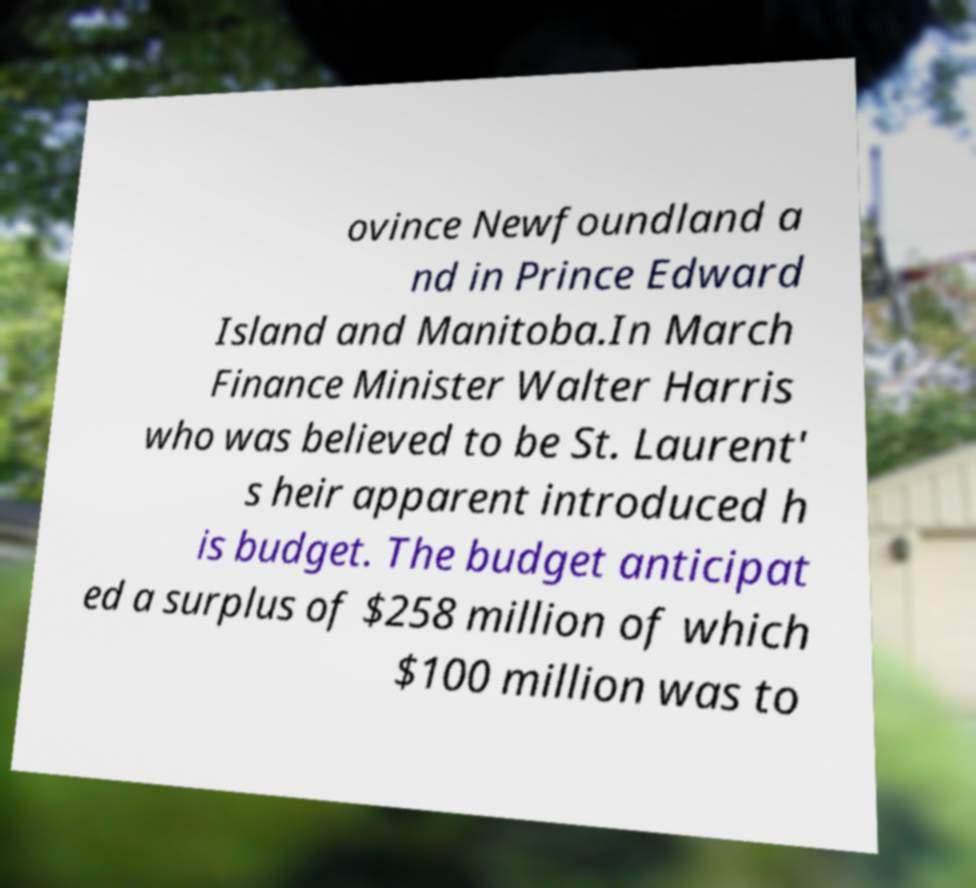I need the written content from this picture converted into text. Can you do that? ovince Newfoundland a nd in Prince Edward Island and Manitoba.In March Finance Minister Walter Harris who was believed to be St. Laurent' s heir apparent introduced h is budget. The budget anticipat ed a surplus of $258 million of which $100 million was to 